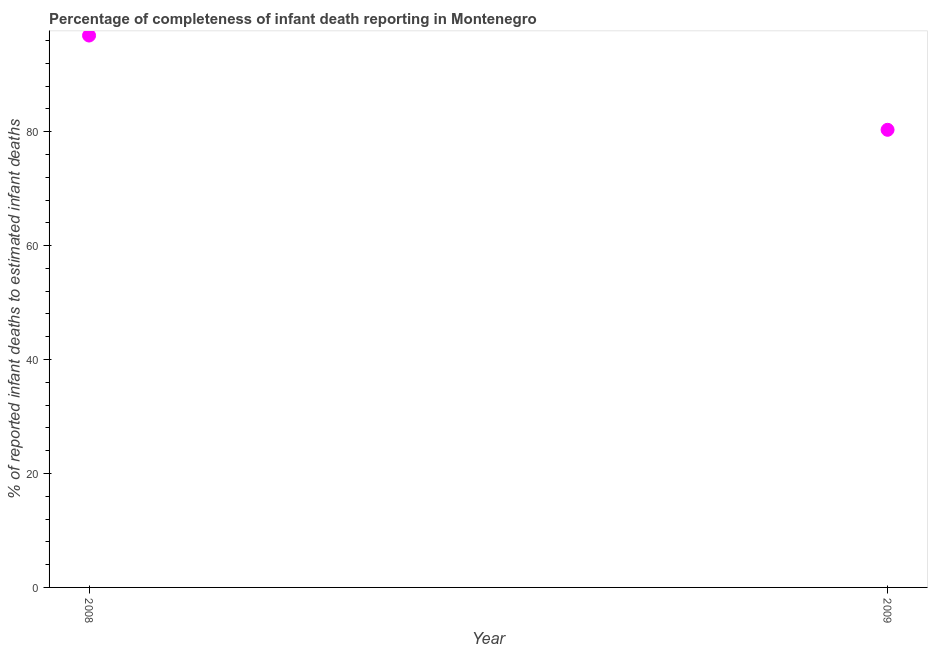What is the completeness of infant death reporting in 2009?
Your answer should be compact. 80.33. Across all years, what is the maximum completeness of infant death reporting?
Ensure brevity in your answer.  96.88. Across all years, what is the minimum completeness of infant death reporting?
Keep it short and to the point. 80.33. In which year was the completeness of infant death reporting maximum?
Your answer should be very brief. 2008. In which year was the completeness of infant death reporting minimum?
Offer a very short reply. 2009. What is the sum of the completeness of infant death reporting?
Offer a terse response. 177.2. What is the difference between the completeness of infant death reporting in 2008 and 2009?
Your response must be concise. 16.55. What is the average completeness of infant death reporting per year?
Offer a terse response. 88.6. What is the median completeness of infant death reporting?
Provide a short and direct response. 88.6. In how many years, is the completeness of infant death reporting greater than 76 %?
Make the answer very short. 2. What is the ratio of the completeness of infant death reporting in 2008 to that in 2009?
Your answer should be compact. 1.21. Is the completeness of infant death reporting in 2008 less than that in 2009?
Give a very brief answer. No. In how many years, is the completeness of infant death reporting greater than the average completeness of infant death reporting taken over all years?
Offer a terse response. 1. How many dotlines are there?
Your answer should be very brief. 1. What is the difference between two consecutive major ticks on the Y-axis?
Ensure brevity in your answer.  20. Are the values on the major ticks of Y-axis written in scientific E-notation?
Provide a succinct answer. No. Does the graph contain any zero values?
Make the answer very short. No. Does the graph contain grids?
Provide a succinct answer. No. What is the title of the graph?
Provide a succinct answer. Percentage of completeness of infant death reporting in Montenegro. What is the label or title of the X-axis?
Ensure brevity in your answer.  Year. What is the label or title of the Y-axis?
Your answer should be very brief. % of reported infant deaths to estimated infant deaths. What is the % of reported infant deaths to estimated infant deaths in 2008?
Provide a short and direct response. 96.88. What is the % of reported infant deaths to estimated infant deaths in 2009?
Your response must be concise. 80.33. What is the difference between the % of reported infant deaths to estimated infant deaths in 2008 and 2009?
Offer a terse response. 16.55. What is the ratio of the % of reported infant deaths to estimated infant deaths in 2008 to that in 2009?
Ensure brevity in your answer.  1.21. 